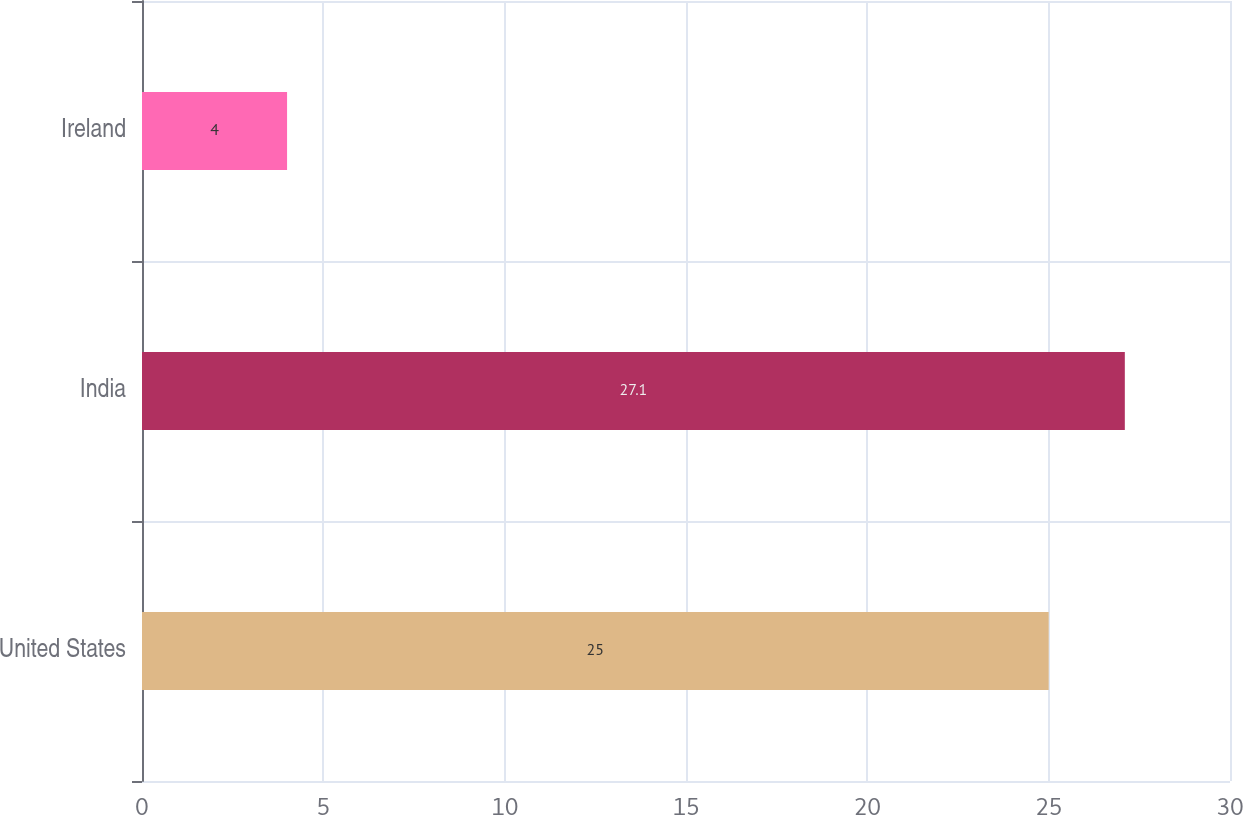Convert chart to OTSL. <chart><loc_0><loc_0><loc_500><loc_500><bar_chart><fcel>United States<fcel>India<fcel>Ireland<nl><fcel>25<fcel>27.1<fcel>4<nl></chart> 